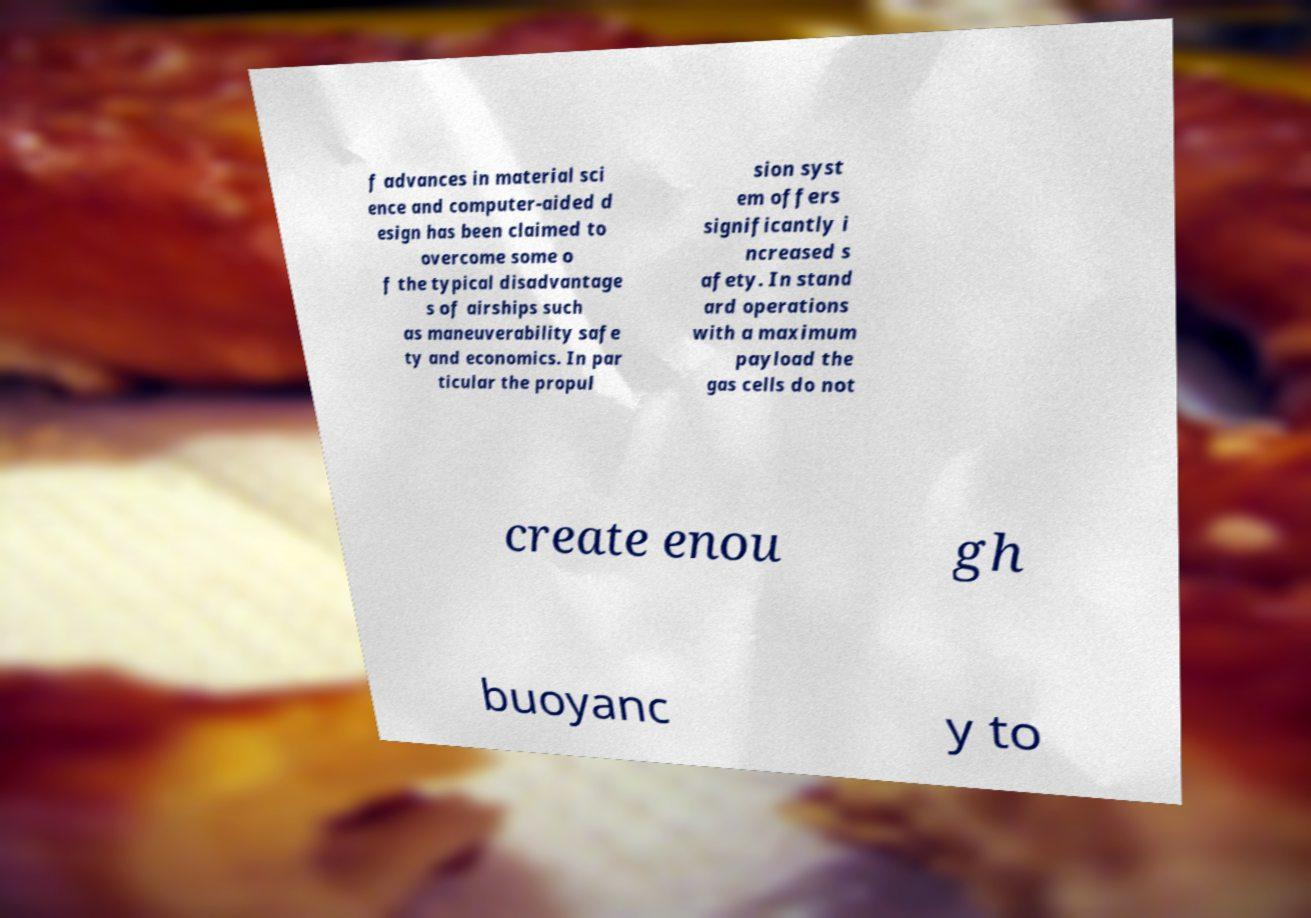Can you accurately transcribe the text from the provided image for me? f advances in material sci ence and computer-aided d esign has been claimed to overcome some o f the typical disadvantage s of airships such as maneuverability safe ty and economics. In par ticular the propul sion syst em offers significantly i ncreased s afety. In stand ard operations with a maximum payload the gas cells do not create enou gh buoyanc y to 